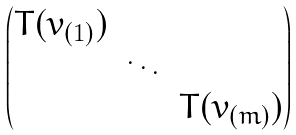<formula> <loc_0><loc_0><loc_500><loc_500>\begin{pmatrix} T ( v _ { ( 1 ) } ) \\ & \ddots \\ & & T ( v _ { ( m ) } ) \end{pmatrix}</formula> 